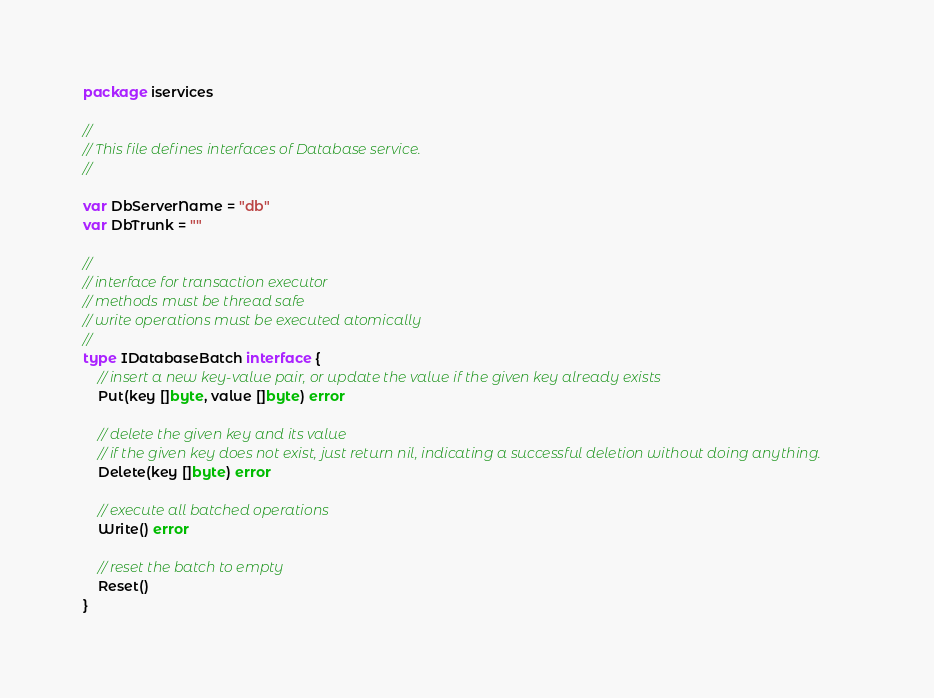<code> <loc_0><loc_0><loc_500><loc_500><_Go_>package iservices

//
// This file defines interfaces of Database service.
//

var DbServerName = "db"
var DbTrunk = ""

//
// interface for transaction executor
// methods must be thread safe
// write operations must be executed atomically
//
type IDatabaseBatch interface {
	// insert a new key-value pair, or update the value if the given key already exists
	Put(key []byte, value []byte) error

	// delete the given key and its value
	// if the given key does not exist, just return nil, indicating a successful deletion without doing anything.
	Delete(key []byte) error

	// execute all batched operations
	Write() error

	// reset the batch to empty
	Reset()
}
</code> 